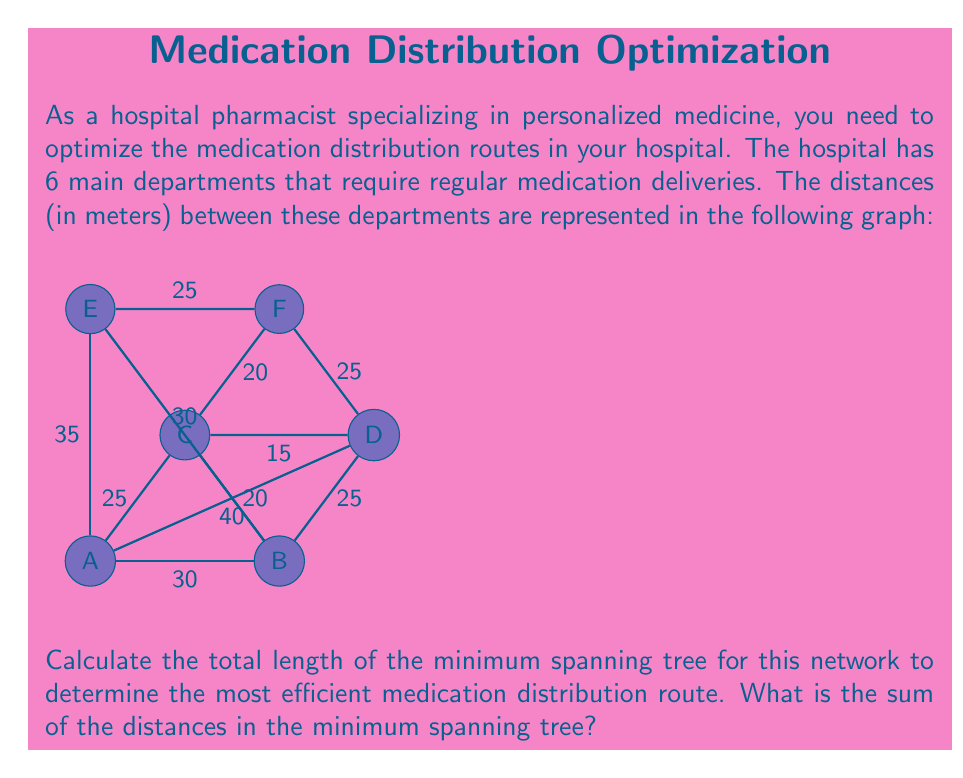Can you answer this question? To find the minimum spanning tree (MST) for this network, we'll use Kruskal's algorithm. This algorithm sorts all edges by weight and adds them to the MST if they don't create a cycle, until all vertices are connected.

Step 1: Sort all edges by weight (ascending order):
1. C-D: 15m
2. B-C: 20m
3. C-F: 20m
4. A-C: 25m
5. B-D: 25m
6. E-F: 25m
7. A-B: 30m
8. B-E: 30m
9. A-E: 35m
10. A-D: 40m

Step 2: Add edges to the MST:
1. Add C-D (15m)
2. Add B-C (20m)
3. Add C-F (20m)
4. Add A-C (25m)
5. Add E-F (25m)

At this point, all vertices are connected, so we stop adding edges.

Step 3: Calculate the total length of the MST:
$$\text{Total length} = 15 + 20 + 20 + 25 + 25 = 105\text{ meters}$$

Therefore, the sum of the distances in the minimum spanning tree is 105 meters.
Answer: 105 meters 